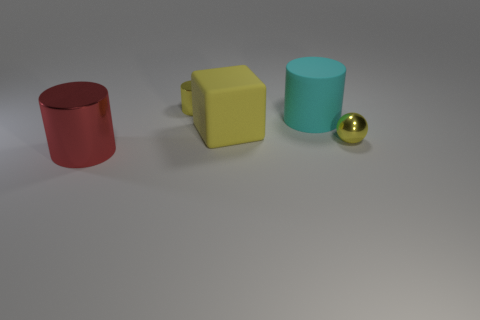Does the cyan matte object have the same shape as the red shiny object?
Provide a succinct answer. Yes. How many big things are either rubber blocks or red cylinders?
Keep it short and to the point. 2. There is a large cube that is made of the same material as the cyan cylinder; what color is it?
Your answer should be very brief. Yellow. What number of other tiny cylinders are made of the same material as the red cylinder?
Your response must be concise. 1. Do the metallic cylinder that is behind the large shiny object and the metallic cylinder that is in front of the cyan rubber cylinder have the same size?
Provide a succinct answer. No. What material is the tiny thing in front of the small yellow cylinder that is left of the cyan object made of?
Your response must be concise. Metal. Are there fewer big cylinders left of the big matte block than large matte things that are to the left of the red thing?
Make the answer very short. No. What is the material of the large thing that is the same color as the small shiny cylinder?
Make the answer very short. Rubber. Are there any other things that have the same shape as the red object?
Give a very brief answer. Yes. There is a tiny yellow thing right of the rubber cylinder; what is its material?
Your answer should be very brief. Metal. 